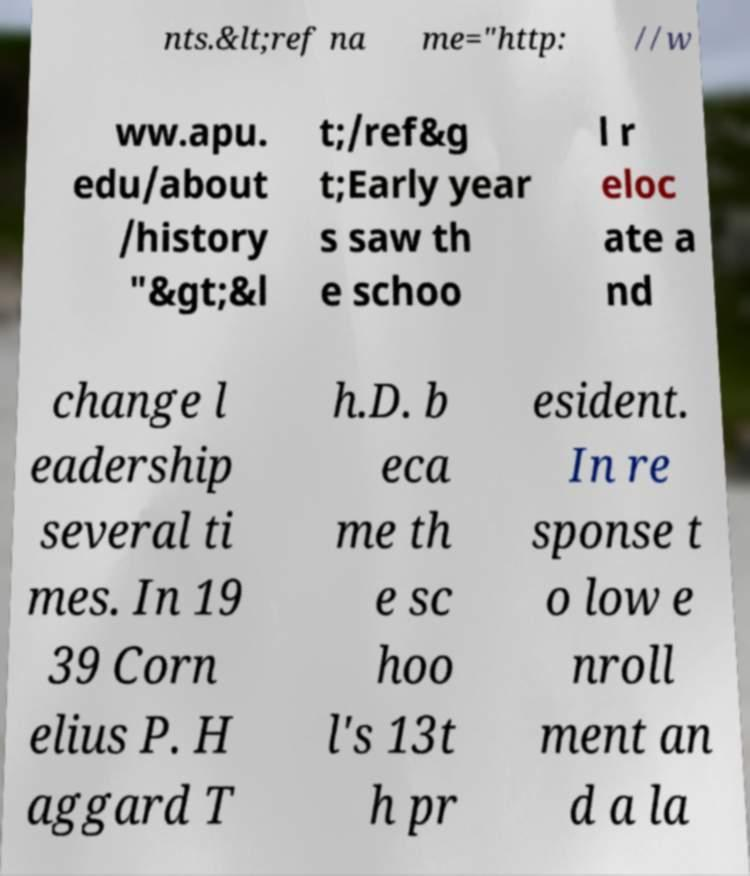There's text embedded in this image that I need extracted. Can you transcribe it verbatim? nts.&lt;ref na me="http: //w ww.apu. edu/about /history "&gt;&l t;/ref&g t;Early year s saw th e schoo l r eloc ate a nd change l eadership several ti mes. In 19 39 Corn elius P. H aggard T h.D. b eca me th e sc hoo l's 13t h pr esident. In re sponse t o low e nroll ment an d a la 